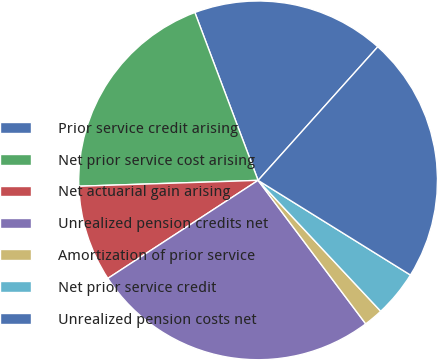Convert chart to OTSL. <chart><loc_0><loc_0><loc_500><loc_500><pie_chart><fcel>Prior service credit arising<fcel>Net prior service cost arising<fcel>Net actuarial gain arising<fcel>Unrealized pension credits net<fcel>Amortization of prior service<fcel>Net prior service credit<fcel>Unrealized pension costs net<nl><fcel>17.36%<fcel>19.79%<fcel>8.68%<fcel>26.04%<fcel>1.74%<fcel>4.17%<fcel>22.22%<nl></chart> 